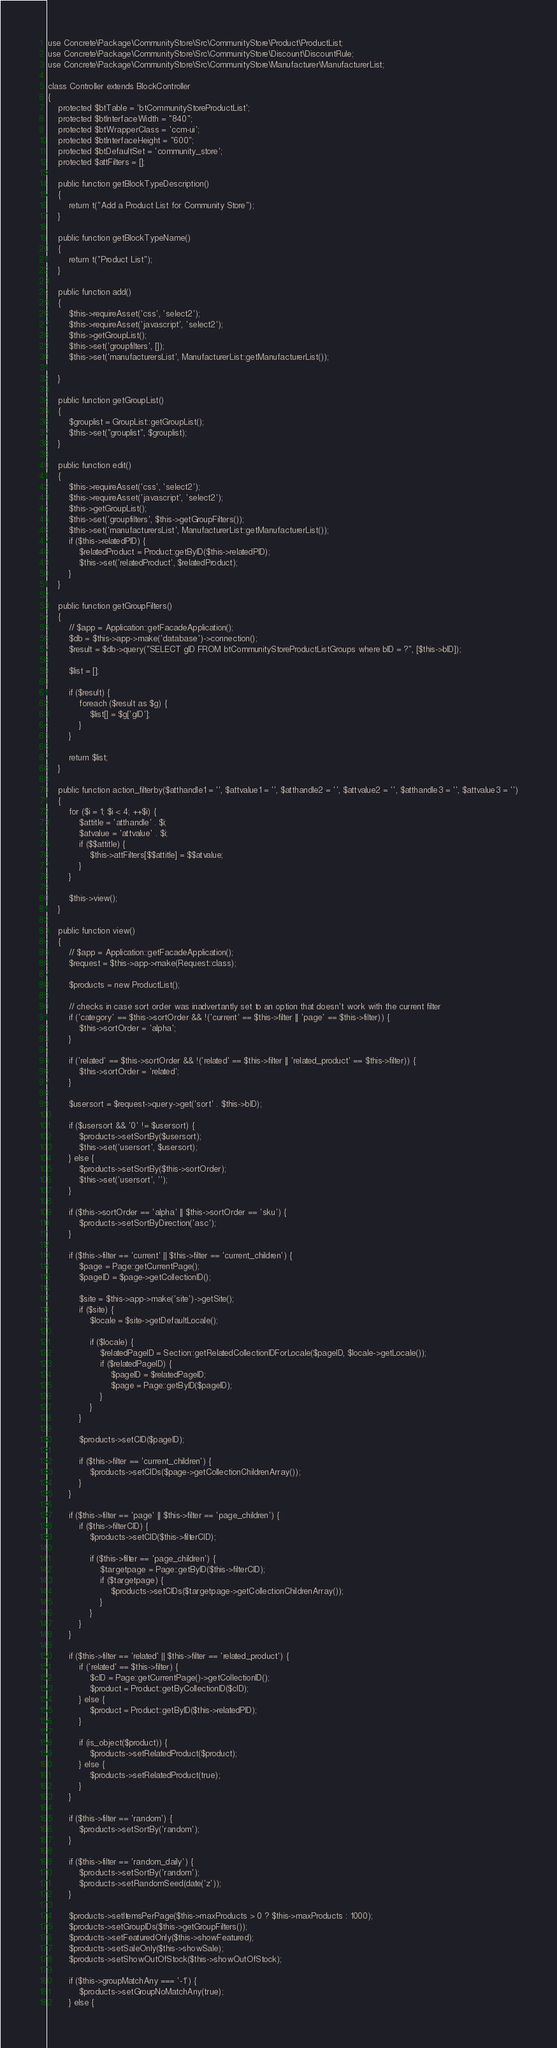<code> <loc_0><loc_0><loc_500><loc_500><_PHP_>use Concrete\Package\CommunityStore\Src\CommunityStore\Product\ProductList;
use Concrete\Package\CommunityStore\Src\CommunityStore\Discount\DiscountRule;
use Concrete\Package\CommunityStore\Src\CommunityStore\Manufacturer\ManufacturerList;

class Controller extends BlockController
{
    protected $btTable = 'btCommunityStoreProductList';
    protected $btInterfaceWidth = "840";
    protected $btWrapperClass = 'ccm-ui';
    protected $btInterfaceHeight = "600";
    protected $btDefaultSet = 'community_store';
    protected $attFilters = [];

    public function getBlockTypeDescription()
    {
        return t("Add a Product List for Community Store");
    }

    public function getBlockTypeName()
    {
        return t("Product List");
    }

    public function add()
    {
        $this->requireAsset('css', 'select2');
        $this->requireAsset('javascript', 'select2');
        $this->getGroupList();
        $this->set('groupfilters', []);
        $this->set('manufacturersList', ManufacturerList::getManufacturerList());

    }

    public function getGroupList()
    {
        $grouplist = GroupList::getGroupList();
        $this->set("grouplist", $grouplist);
    }

    public function edit()
    {
        $this->requireAsset('css', 'select2');
        $this->requireAsset('javascript', 'select2');
        $this->getGroupList();
        $this->set('groupfilters', $this->getGroupFilters());
        $this->set('manufacturersList', ManufacturerList::getManufacturerList());
        if ($this->relatedPID) {
            $relatedProduct = Product::getByID($this->relatedPID);
            $this->set('relatedProduct', $relatedProduct);
        }
    }

    public function getGroupFilters()
    {
        // $app = Application::getFacadeApplication();
        $db = $this->app->make('database')->connection();
        $result = $db->query("SELECT gID FROM btCommunityStoreProductListGroups where bID = ?", [$this->bID]);

        $list = [];

        if ($result) {
            foreach ($result as $g) {
                $list[] = $g['gID'];
            }
        }

        return $list;
    }

    public function action_filterby($atthandle1 = '', $attvalue1 = '', $atthandle2 = '', $attvalue2 = '', $atthandle3 = '', $attvalue3 = '')
    {
        for ($i = 1; $i < 4; ++$i) {
            $attitle = 'atthandle' . $i;
            $atvalue = 'attvalue' . $i;
            if ($$attitle) {
                $this->attFilters[$$attitle] = $$atvalue;
            }
        }

        $this->view();
    }

    public function view()
    {
        // $app = Application::getFacadeApplication();
        $request = $this->app->make(Request::class);

        $products = new ProductList();

        // checks in case sort order was inadvertantly set to an option that doesn't work with the current filter
        if ('category' == $this->sortOrder && !('current' == $this->filter || 'page' == $this->filter)) {
            $this->sortOrder = 'alpha';
        }

        if ('related' == $this->sortOrder && !('related' == $this->filter || 'related_product' == $this->filter)) {
            $this->sortOrder = 'related';
        }

        $usersort = $request->query->get('sort' . $this->bID);

        if ($usersort && '0' != $usersort) {
            $products->setSortBy($usersort);
            $this->set('usersort', $usersort);
        } else {
            $products->setSortBy($this->sortOrder);
            $this->set('usersort', '');
        }

        if ($this->sortOrder == 'alpha' || $this->sortOrder == 'sku') {
            $products->setSortByDirection('asc');
        }

        if ($this->filter == 'current' || $this->filter == 'current_children') {
            $page = Page::getCurrentPage();
            $pageID = $page->getCollectionID();

            $site = $this->app->make('site')->getSite();
            if ($site) {
                $locale = $site->getDefaultLocale();

                if ($locale) {
                    $relatedPageID = Section::getRelatedCollectionIDForLocale($pageID, $locale->getLocale());
                    if ($relatedPageID) {
                        $pageID = $relatedPageID;
                        $page = Page::getByID($pageID);
                    }
                }
            }

            $products->setCID($pageID);

            if ($this->filter == 'current_children') {
                $products->setCIDs($page->getCollectionChildrenArray());
            }
        }

        if ($this->filter == 'page' || $this->filter == 'page_children') {
            if ($this->filterCID) {
                $products->setCID($this->filterCID);

                if ($this->filter == 'page_children') {
                    $targetpage = Page::getByID($this->filterCID);
                    if ($targetpage) {
                        $products->setCIDs($targetpage->getCollectionChildrenArray());
                    }
                }
            }
        }

        if ($this->filter == 'related' || $this->filter == 'related_product') {
            if ('related' == $this->filter) {
                $cID = Page::getCurrentPage()->getCollectionID();
                $product = Product::getByCollectionID($cID);
            } else {
                $product = Product::getByID($this->relatedPID);
            }

            if (is_object($product)) {
                $products->setRelatedProduct($product);
            } else {
                $products->setRelatedProduct(true);
            }
        }

        if ($this->filter == 'random') {
            $products->setSortBy('random');
        }

        if ($this->filter == 'random_daily') {
            $products->setSortBy('random');
            $products->setRandomSeed(date('z'));
        }

        $products->setItemsPerPage($this->maxProducts > 0 ? $this->maxProducts : 1000);
        $products->setGroupIDs($this->getGroupFilters());
        $products->setFeaturedOnly($this->showFeatured);
        $products->setSaleOnly($this->showSale);
        $products->setShowOutOfStock($this->showOutOfStock);

        if ($this->groupMatchAny === '-1') {
            $products->setGroupNoMatchAny(true);
        } else {</code> 